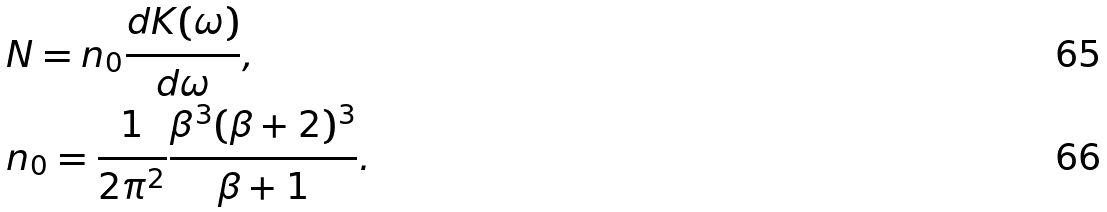<formula> <loc_0><loc_0><loc_500><loc_500>& N = n _ { 0 } \frac { d K ( \omega ) } { d \omega } , \\ & n _ { 0 } = \frac { 1 } { 2 \pi ^ { 2 } } \frac { \beta ^ { 3 } ( \beta + 2 ) ^ { 3 } } { \beta + 1 } .</formula> 